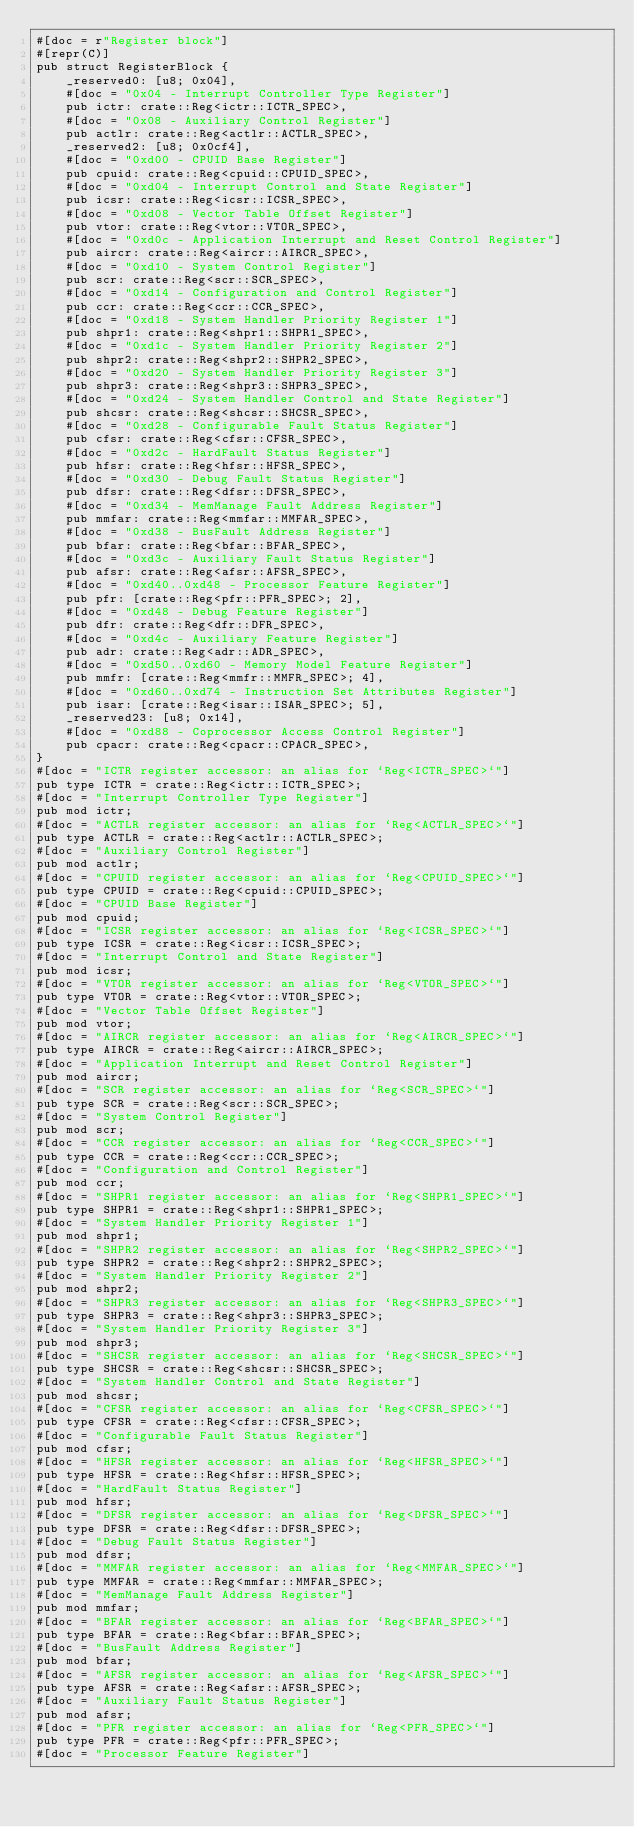Convert code to text. <code><loc_0><loc_0><loc_500><loc_500><_Rust_>#[doc = r"Register block"]
#[repr(C)]
pub struct RegisterBlock {
    _reserved0: [u8; 0x04],
    #[doc = "0x04 - Interrupt Controller Type Register"]
    pub ictr: crate::Reg<ictr::ICTR_SPEC>,
    #[doc = "0x08 - Auxiliary Control Register"]
    pub actlr: crate::Reg<actlr::ACTLR_SPEC>,
    _reserved2: [u8; 0x0cf4],
    #[doc = "0xd00 - CPUID Base Register"]
    pub cpuid: crate::Reg<cpuid::CPUID_SPEC>,
    #[doc = "0xd04 - Interrupt Control and State Register"]
    pub icsr: crate::Reg<icsr::ICSR_SPEC>,
    #[doc = "0xd08 - Vector Table Offset Register"]
    pub vtor: crate::Reg<vtor::VTOR_SPEC>,
    #[doc = "0xd0c - Application Interrupt and Reset Control Register"]
    pub aircr: crate::Reg<aircr::AIRCR_SPEC>,
    #[doc = "0xd10 - System Control Register"]
    pub scr: crate::Reg<scr::SCR_SPEC>,
    #[doc = "0xd14 - Configuration and Control Register"]
    pub ccr: crate::Reg<ccr::CCR_SPEC>,
    #[doc = "0xd18 - System Handler Priority Register 1"]
    pub shpr1: crate::Reg<shpr1::SHPR1_SPEC>,
    #[doc = "0xd1c - System Handler Priority Register 2"]
    pub shpr2: crate::Reg<shpr2::SHPR2_SPEC>,
    #[doc = "0xd20 - System Handler Priority Register 3"]
    pub shpr3: crate::Reg<shpr3::SHPR3_SPEC>,
    #[doc = "0xd24 - System Handler Control and State Register"]
    pub shcsr: crate::Reg<shcsr::SHCSR_SPEC>,
    #[doc = "0xd28 - Configurable Fault Status Register"]
    pub cfsr: crate::Reg<cfsr::CFSR_SPEC>,
    #[doc = "0xd2c - HardFault Status Register"]
    pub hfsr: crate::Reg<hfsr::HFSR_SPEC>,
    #[doc = "0xd30 - Debug Fault Status Register"]
    pub dfsr: crate::Reg<dfsr::DFSR_SPEC>,
    #[doc = "0xd34 - MemManage Fault Address Register"]
    pub mmfar: crate::Reg<mmfar::MMFAR_SPEC>,
    #[doc = "0xd38 - BusFault Address Register"]
    pub bfar: crate::Reg<bfar::BFAR_SPEC>,
    #[doc = "0xd3c - Auxiliary Fault Status Register"]
    pub afsr: crate::Reg<afsr::AFSR_SPEC>,
    #[doc = "0xd40..0xd48 - Processor Feature Register"]
    pub pfr: [crate::Reg<pfr::PFR_SPEC>; 2],
    #[doc = "0xd48 - Debug Feature Register"]
    pub dfr: crate::Reg<dfr::DFR_SPEC>,
    #[doc = "0xd4c - Auxiliary Feature Register"]
    pub adr: crate::Reg<adr::ADR_SPEC>,
    #[doc = "0xd50..0xd60 - Memory Model Feature Register"]
    pub mmfr: [crate::Reg<mmfr::MMFR_SPEC>; 4],
    #[doc = "0xd60..0xd74 - Instruction Set Attributes Register"]
    pub isar: [crate::Reg<isar::ISAR_SPEC>; 5],
    _reserved23: [u8; 0x14],
    #[doc = "0xd88 - Coprocessor Access Control Register"]
    pub cpacr: crate::Reg<cpacr::CPACR_SPEC>,
}
#[doc = "ICTR register accessor: an alias for `Reg<ICTR_SPEC>`"]
pub type ICTR = crate::Reg<ictr::ICTR_SPEC>;
#[doc = "Interrupt Controller Type Register"]
pub mod ictr;
#[doc = "ACTLR register accessor: an alias for `Reg<ACTLR_SPEC>`"]
pub type ACTLR = crate::Reg<actlr::ACTLR_SPEC>;
#[doc = "Auxiliary Control Register"]
pub mod actlr;
#[doc = "CPUID register accessor: an alias for `Reg<CPUID_SPEC>`"]
pub type CPUID = crate::Reg<cpuid::CPUID_SPEC>;
#[doc = "CPUID Base Register"]
pub mod cpuid;
#[doc = "ICSR register accessor: an alias for `Reg<ICSR_SPEC>`"]
pub type ICSR = crate::Reg<icsr::ICSR_SPEC>;
#[doc = "Interrupt Control and State Register"]
pub mod icsr;
#[doc = "VTOR register accessor: an alias for `Reg<VTOR_SPEC>`"]
pub type VTOR = crate::Reg<vtor::VTOR_SPEC>;
#[doc = "Vector Table Offset Register"]
pub mod vtor;
#[doc = "AIRCR register accessor: an alias for `Reg<AIRCR_SPEC>`"]
pub type AIRCR = crate::Reg<aircr::AIRCR_SPEC>;
#[doc = "Application Interrupt and Reset Control Register"]
pub mod aircr;
#[doc = "SCR register accessor: an alias for `Reg<SCR_SPEC>`"]
pub type SCR = crate::Reg<scr::SCR_SPEC>;
#[doc = "System Control Register"]
pub mod scr;
#[doc = "CCR register accessor: an alias for `Reg<CCR_SPEC>`"]
pub type CCR = crate::Reg<ccr::CCR_SPEC>;
#[doc = "Configuration and Control Register"]
pub mod ccr;
#[doc = "SHPR1 register accessor: an alias for `Reg<SHPR1_SPEC>`"]
pub type SHPR1 = crate::Reg<shpr1::SHPR1_SPEC>;
#[doc = "System Handler Priority Register 1"]
pub mod shpr1;
#[doc = "SHPR2 register accessor: an alias for `Reg<SHPR2_SPEC>`"]
pub type SHPR2 = crate::Reg<shpr2::SHPR2_SPEC>;
#[doc = "System Handler Priority Register 2"]
pub mod shpr2;
#[doc = "SHPR3 register accessor: an alias for `Reg<SHPR3_SPEC>`"]
pub type SHPR3 = crate::Reg<shpr3::SHPR3_SPEC>;
#[doc = "System Handler Priority Register 3"]
pub mod shpr3;
#[doc = "SHCSR register accessor: an alias for `Reg<SHCSR_SPEC>`"]
pub type SHCSR = crate::Reg<shcsr::SHCSR_SPEC>;
#[doc = "System Handler Control and State Register"]
pub mod shcsr;
#[doc = "CFSR register accessor: an alias for `Reg<CFSR_SPEC>`"]
pub type CFSR = crate::Reg<cfsr::CFSR_SPEC>;
#[doc = "Configurable Fault Status Register"]
pub mod cfsr;
#[doc = "HFSR register accessor: an alias for `Reg<HFSR_SPEC>`"]
pub type HFSR = crate::Reg<hfsr::HFSR_SPEC>;
#[doc = "HardFault Status Register"]
pub mod hfsr;
#[doc = "DFSR register accessor: an alias for `Reg<DFSR_SPEC>`"]
pub type DFSR = crate::Reg<dfsr::DFSR_SPEC>;
#[doc = "Debug Fault Status Register"]
pub mod dfsr;
#[doc = "MMFAR register accessor: an alias for `Reg<MMFAR_SPEC>`"]
pub type MMFAR = crate::Reg<mmfar::MMFAR_SPEC>;
#[doc = "MemManage Fault Address Register"]
pub mod mmfar;
#[doc = "BFAR register accessor: an alias for `Reg<BFAR_SPEC>`"]
pub type BFAR = crate::Reg<bfar::BFAR_SPEC>;
#[doc = "BusFault Address Register"]
pub mod bfar;
#[doc = "AFSR register accessor: an alias for `Reg<AFSR_SPEC>`"]
pub type AFSR = crate::Reg<afsr::AFSR_SPEC>;
#[doc = "Auxiliary Fault Status Register"]
pub mod afsr;
#[doc = "PFR register accessor: an alias for `Reg<PFR_SPEC>`"]
pub type PFR = crate::Reg<pfr::PFR_SPEC>;
#[doc = "Processor Feature Register"]</code> 